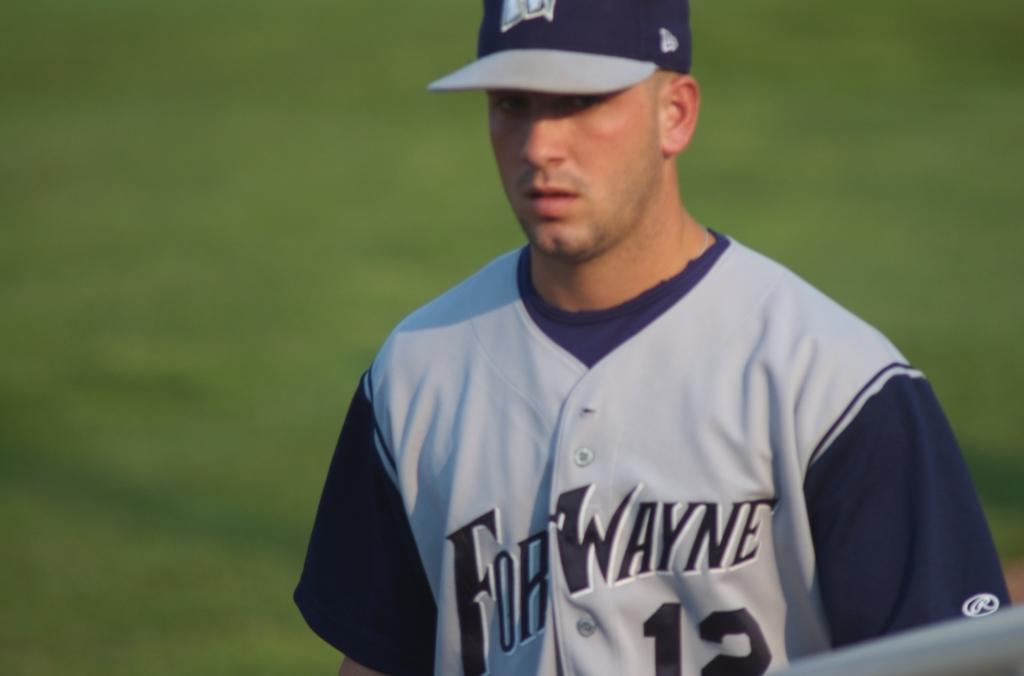Is that player 12?
Give a very brief answer. Yes. What´s the player´s team name?
Your response must be concise. Fort wayne. 